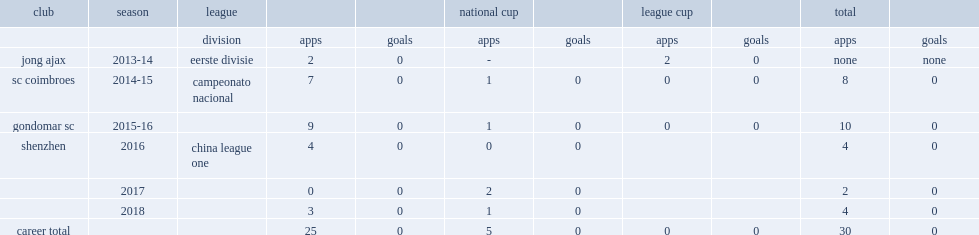In 2016, which league did wang join side shenzhen? China league one. 